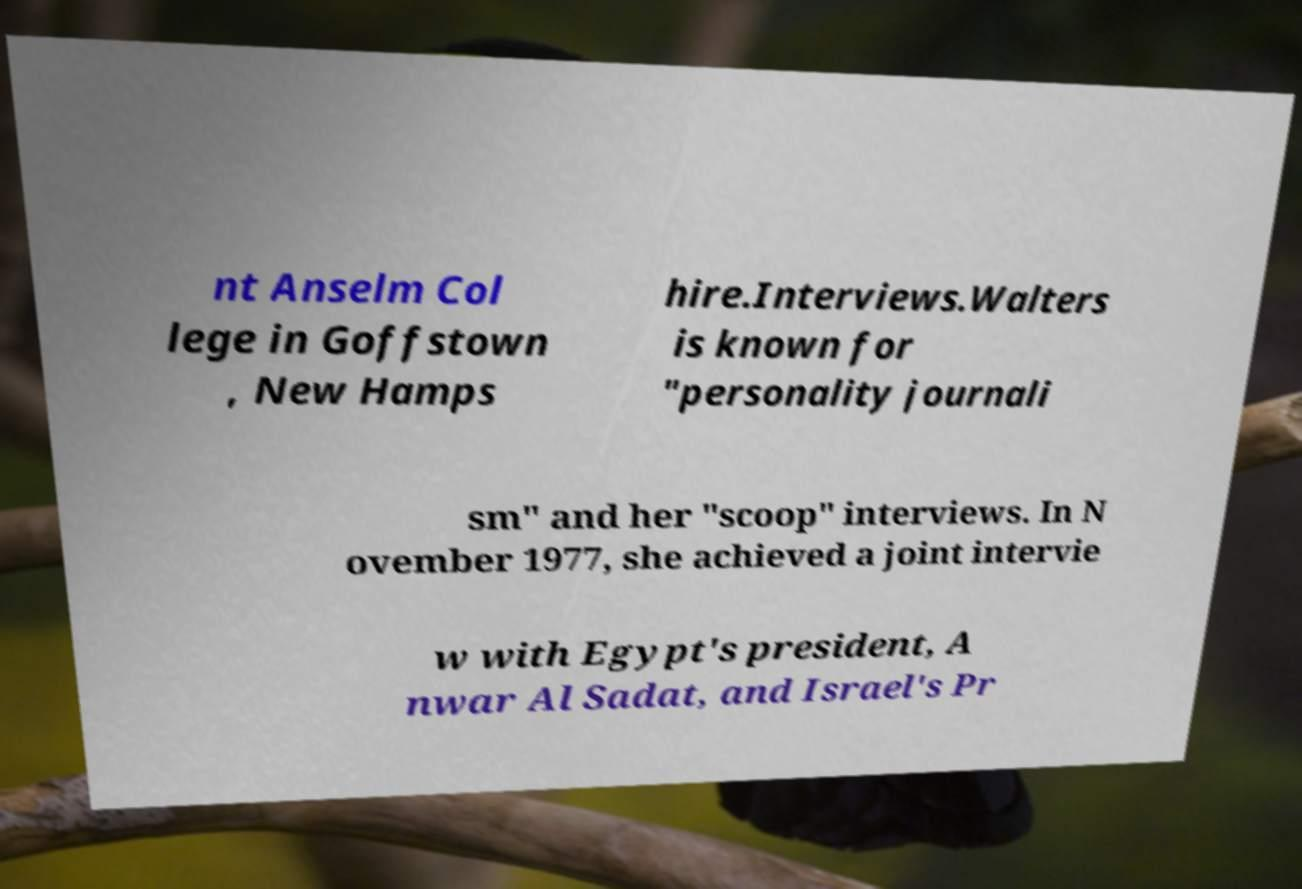There's text embedded in this image that I need extracted. Can you transcribe it verbatim? nt Anselm Col lege in Goffstown , New Hamps hire.Interviews.Walters is known for "personality journali sm" and her "scoop" interviews. In N ovember 1977, she achieved a joint intervie w with Egypt's president, A nwar Al Sadat, and Israel's Pr 